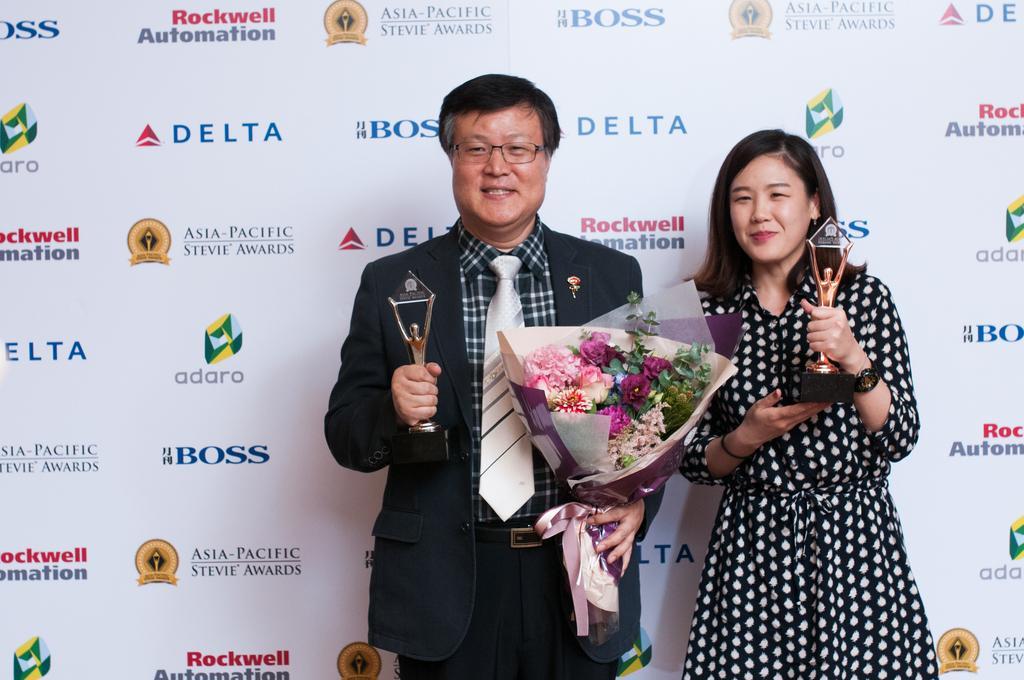Could you give a brief overview of what you see in this image? In this image there is a man and a woman standing. They are holding trophies in their hands. The man is also holding a bouquet. Behind them there is a banner. There are logos and text on the banner. 